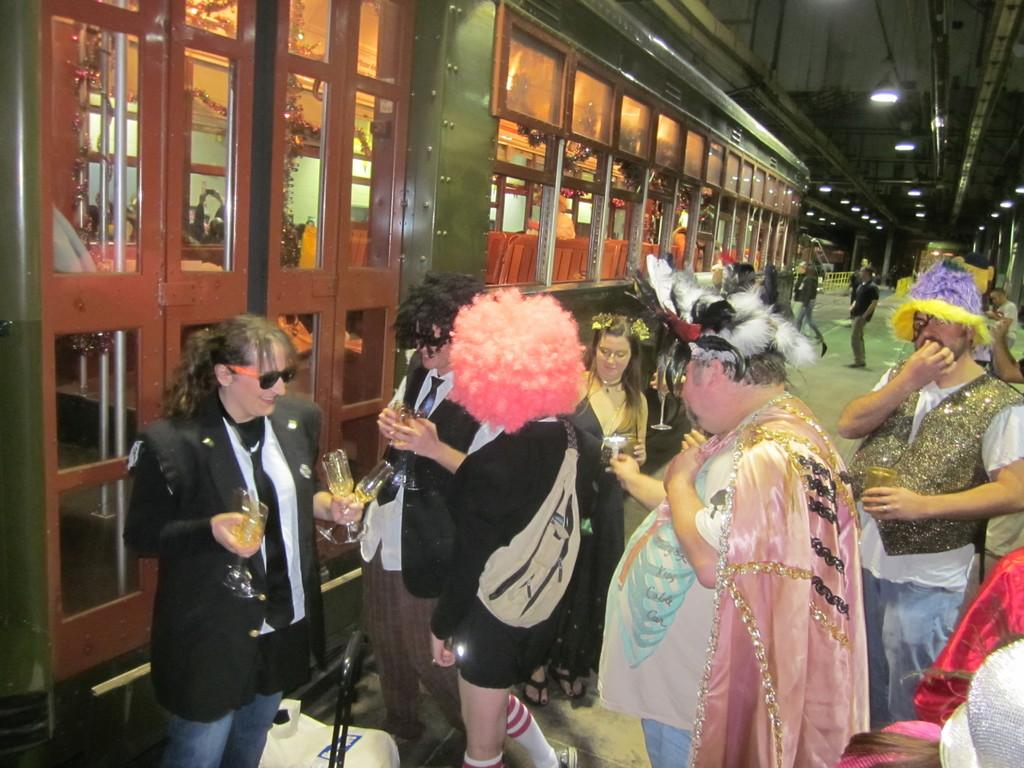What are the people in the image wearing? The people in the image are wearing costumes. What are some people holding in the image? Some people are holding glasses in the image. What type of architectural feature can be seen in the image? There are glass doors and windows in the image. What is present on the ceiling in the image? There are lights on the ceiling in the image. What type of bait is being used to catch mice in the image? There is no bait or mice present in the image. What is the name of the town where the image was taken? The provided facts do not mention the location or name of a town where the image was taken. 